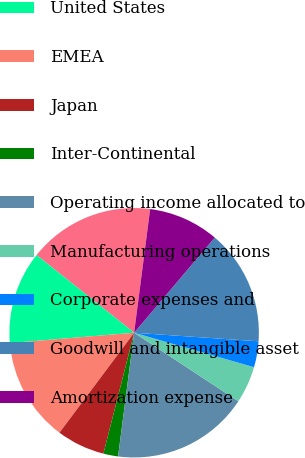Convert chart. <chart><loc_0><loc_0><loc_500><loc_500><pie_chart><fcel>(in millions)<fcel>United States<fcel>EMEA<fcel>Japan<fcel>Inter-Continental<fcel>Operating income allocated to<fcel>Manufacturing operations<fcel>Corporate expenses and<fcel>Goodwill and intangible asset<fcel>Amortization expense<nl><fcel>16.35%<fcel>12.02%<fcel>13.47%<fcel>6.25%<fcel>1.91%<fcel>17.8%<fcel>4.8%<fcel>3.36%<fcel>14.91%<fcel>9.13%<nl></chart> 